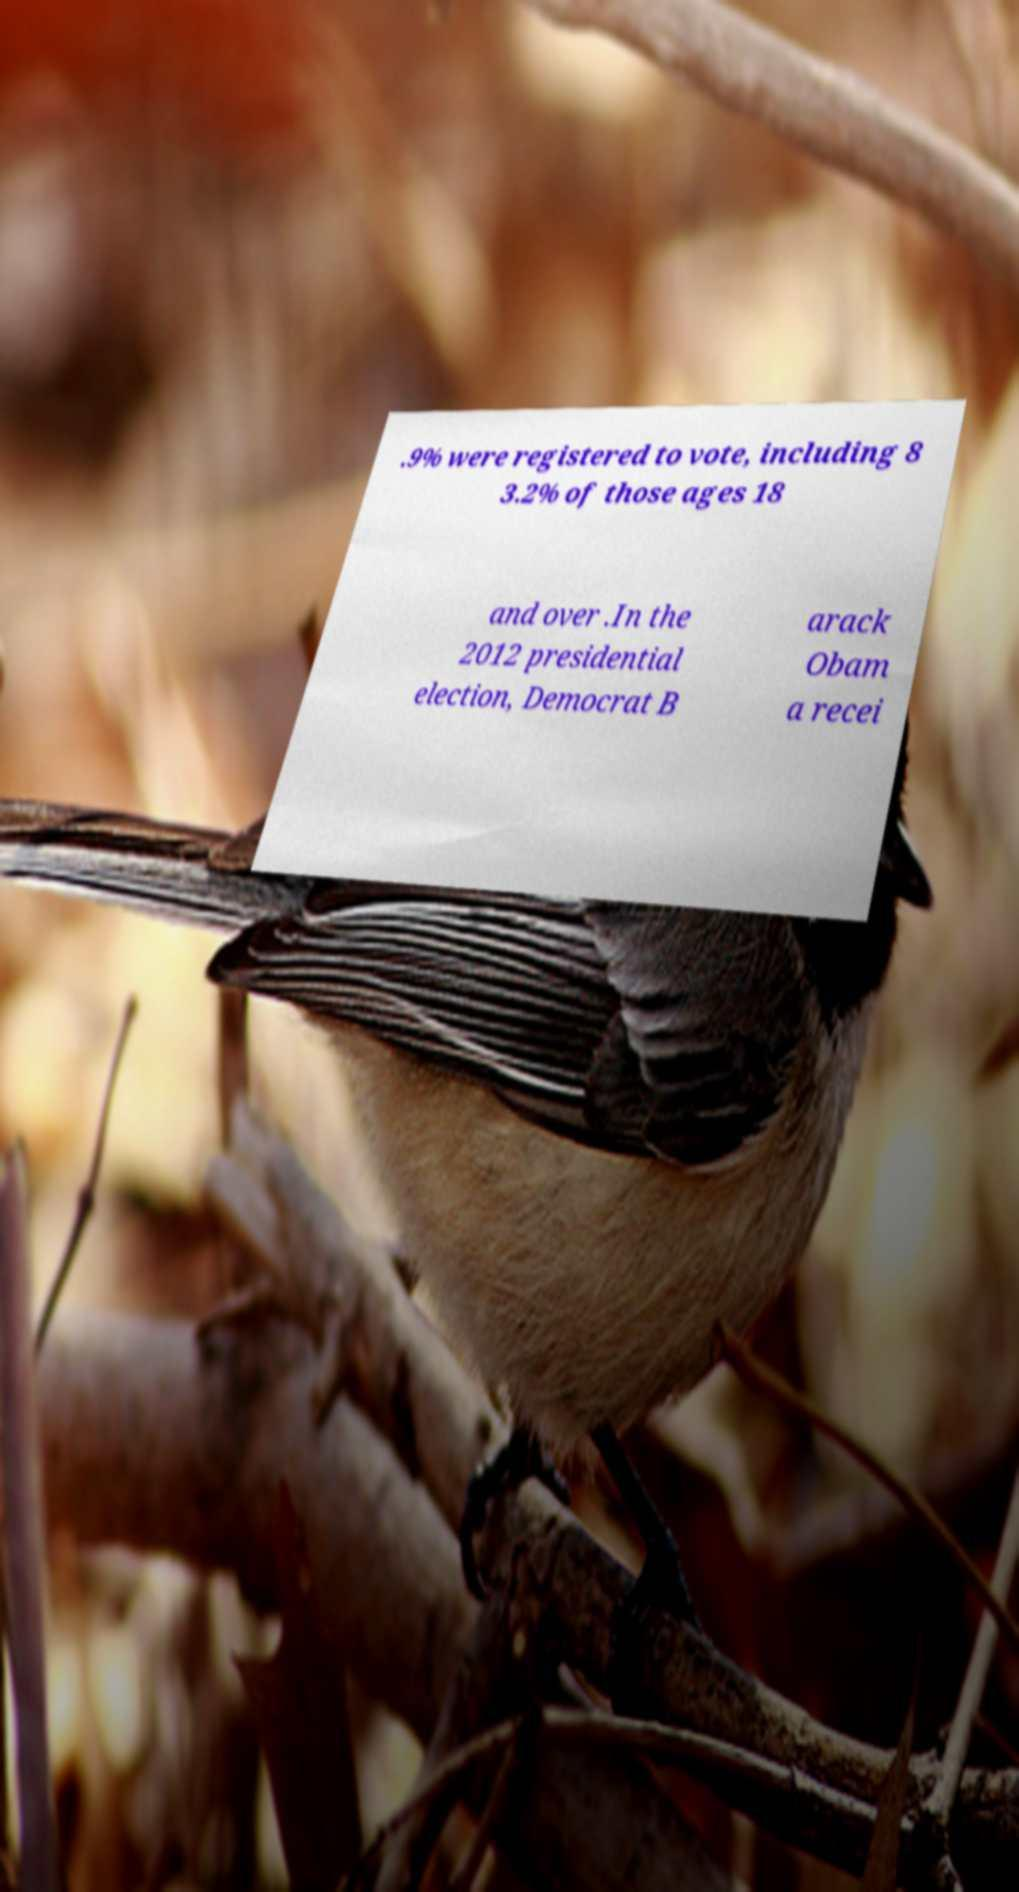Please read and relay the text visible in this image. What does it say? .9% were registered to vote, including 8 3.2% of those ages 18 and over .In the 2012 presidential election, Democrat B arack Obam a recei 